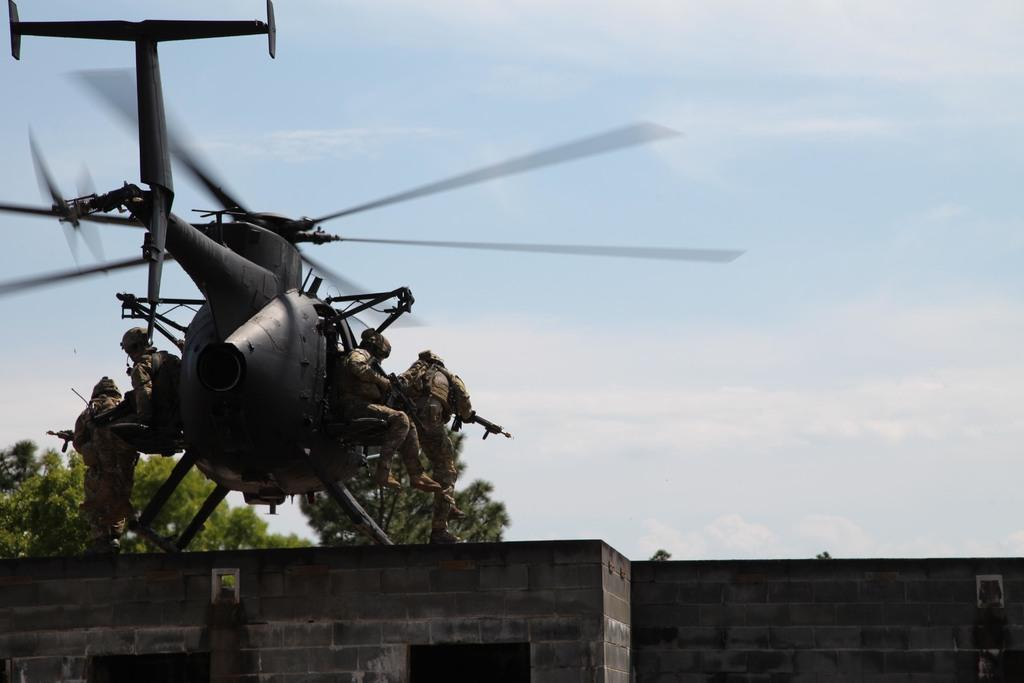What is the main subject of the image? The main subject of the image is a helicopter. Are there any people in the image? Yes, there are people in the image. What can be seen in the background of the image? There is a wall and trees in the image, as well as the sky. What is the condition of the sky in the image? The sky is visible in the image, and clouds are present. Can you tell me what verse the tiger is reciting in the image? There is no tiger or verse present in the image; it features a helicopter, people, a wall, trees, and a sky with clouds. 